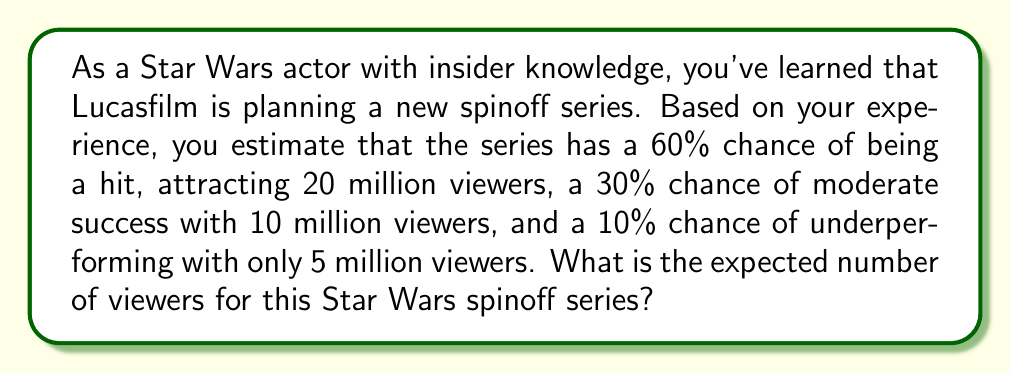Solve this math problem. To calculate the expected number of viewers, we need to use the concept of expected value. The expected value is the sum of each possible outcome multiplied by its probability.

Let's break it down step by step:

1) We have three possible outcomes:
   - Hit: 20 million viewers with 60% probability
   - Moderate success: 10 million viewers with 30% probability
   - Underperforming: 5 million viewers with 10% probability

2) Let's calculate the contribution of each outcome to the expected value:
   - Hit: $20 \times 0.60 = 12$ million
   - Moderate success: $10 \times 0.30 = 3$ million
   - Underperforming: $5 \times 0.10 = 0.5$ million

3) The expected value is the sum of these contributions:

   $$E(\text{viewers}) = (20 \times 0.60) + (10 \times 0.30) + (5 \times 0.10)$$
   $$E(\text{viewers}) = 12 + 3 + 0.5 = 15.5$$

Therefore, the expected number of viewers for the Star Wars spinoff series is 15.5 million.
Answer: 15.5 million viewers 